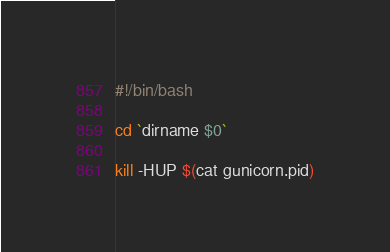<code> <loc_0><loc_0><loc_500><loc_500><_Bash_>#!/bin/bash

cd `dirname $0`

kill -HUP $(cat gunicorn.pid)
</code> 